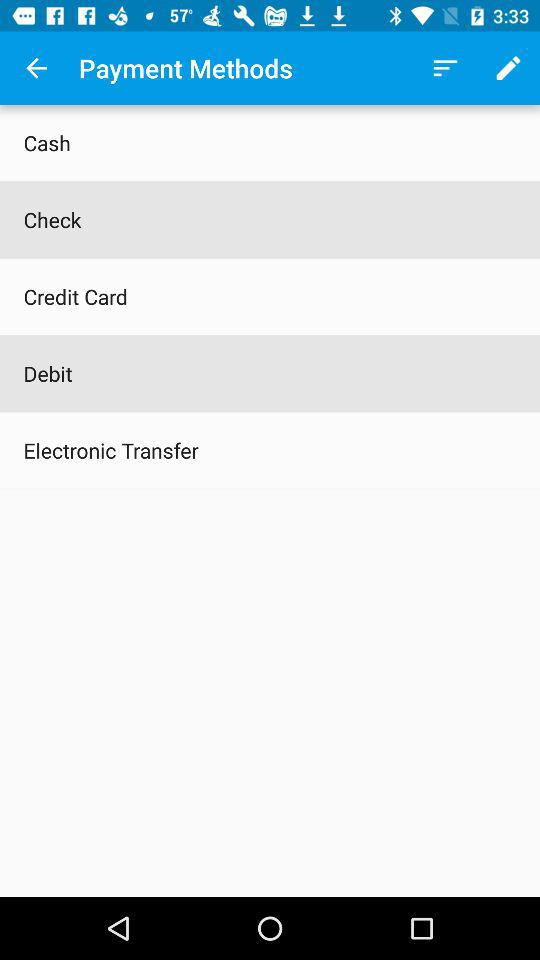How many payment methods are there?
Answer the question using a single word or phrase. 5 